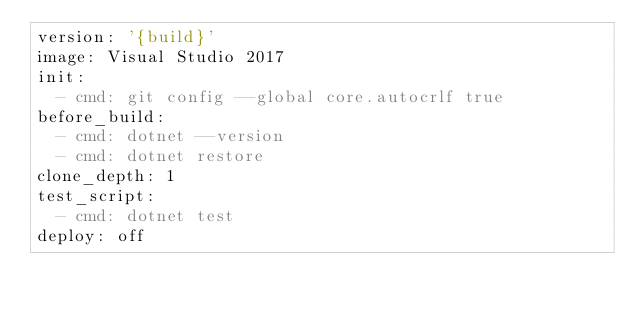Convert code to text. <code><loc_0><loc_0><loc_500><loc_500><_YAML_>version: '{build}'
image: Visual Studio 2017
init:
  - cmd: git config --global core.autocrlf true
before_build:
  - cmd: dotnet --version
  - cmd: dotnet restore
clone_depth: 1
test_script:
  - cmd: dotnet test
deploy: off
</code> 